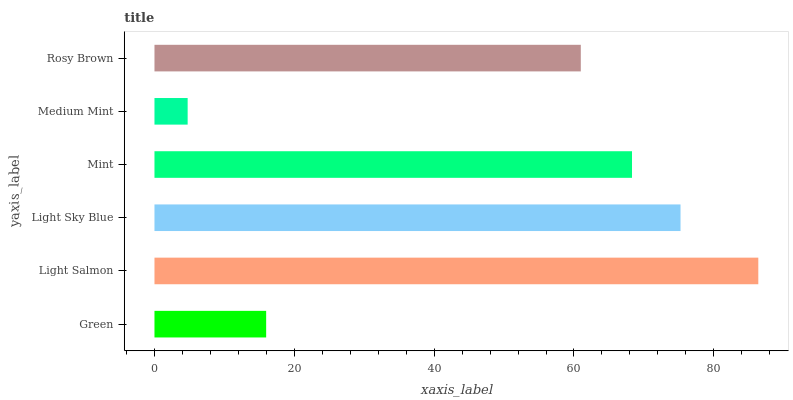Is Medium Mint the minimum?
Answer yes or no. Yes. Is Light Salmon the maximum?
Answer yes or no. Yes. Is Light Sky Blue the minimum?
Answer yes or no. No. Is Light Sky Blue the maximum?
Answer yes or no. No. Is Light Salmon greater than Light Sky Blue?
Answer yes or no. Yes. Is Light Sky Blue less than Light Salmon?
Answer yes or no. Yes. Is Light Sky Blue greater than Light Salmon?
Answer yes or no. No. Is Light Salmon less than Light Sky Blue?
Answer yes or no. No. Is Mint the high median?
Answer yes or no. Yes. Is Rosy Brown the low median?
Answer yes or no. Yes. Is Light Sky Blue the high median?
Answer yes or no. No. Is Light Salmon the low median?
Answer yes or no. No. 